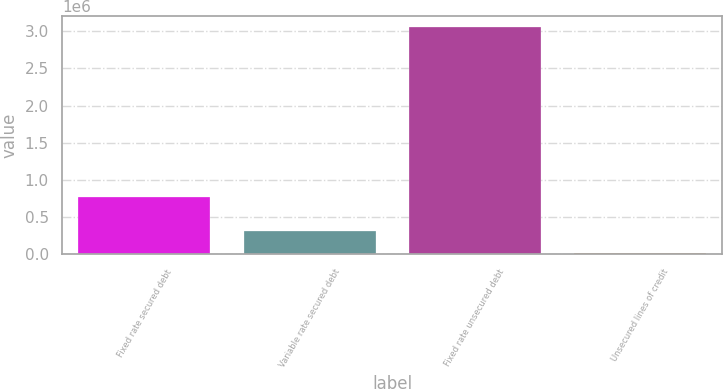Convert chart. <chart><loc_0><loc_0><loc_500><loc_500><bar_chart><fcel>Fixed rate secured debt<fcel>Variable rate secured debt<fcel>Fixed rate unsecured debt<fcel>Unsecured lines of credit<nl><fcel>766299<fcel>319440<fcel>3.05246e+06<fcel>15770<nl></chart> 